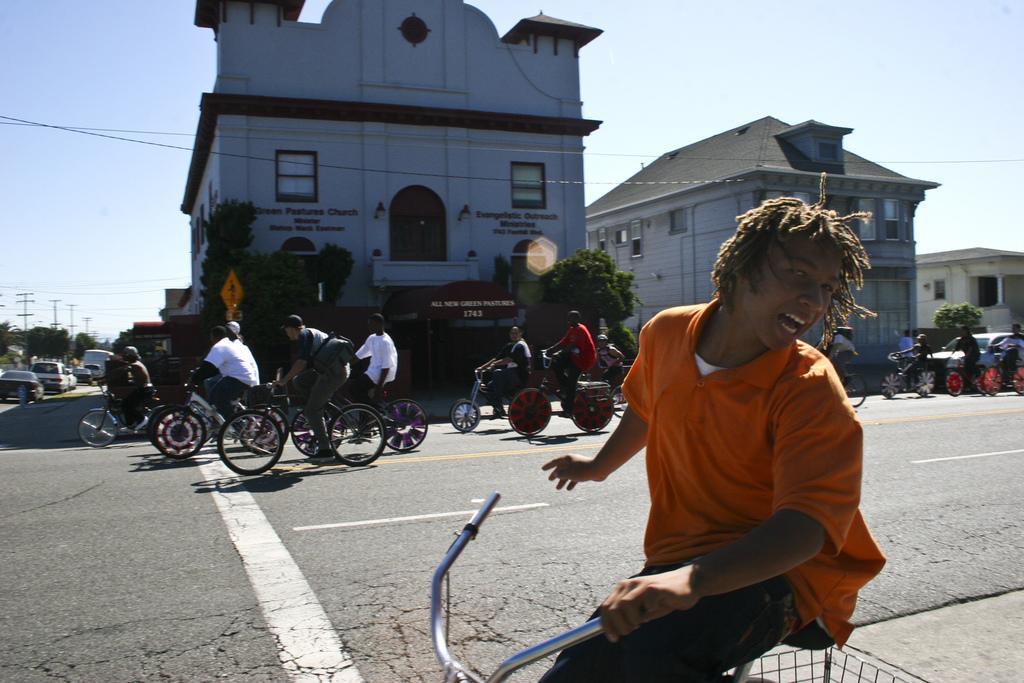How would you summarize this image in a sentence or two? people are riding bicycles on the road. behind them there are cars. at the back there are buildings and trees. 